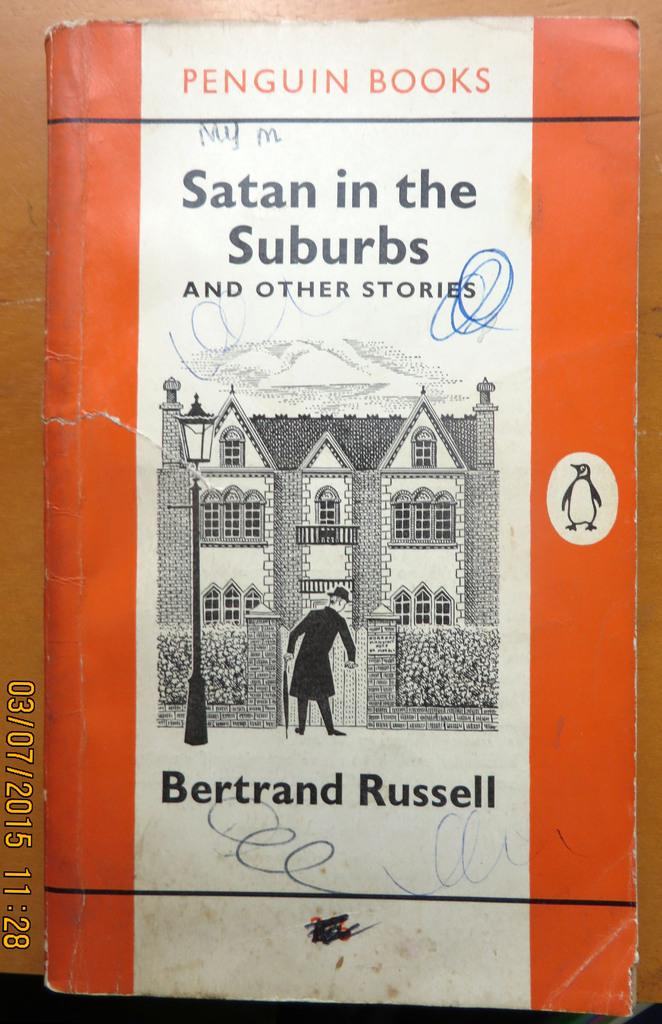<image>
Create a compact narrative representing the image presented. A Penguin Book titles, "Satan in the Suburbs." 